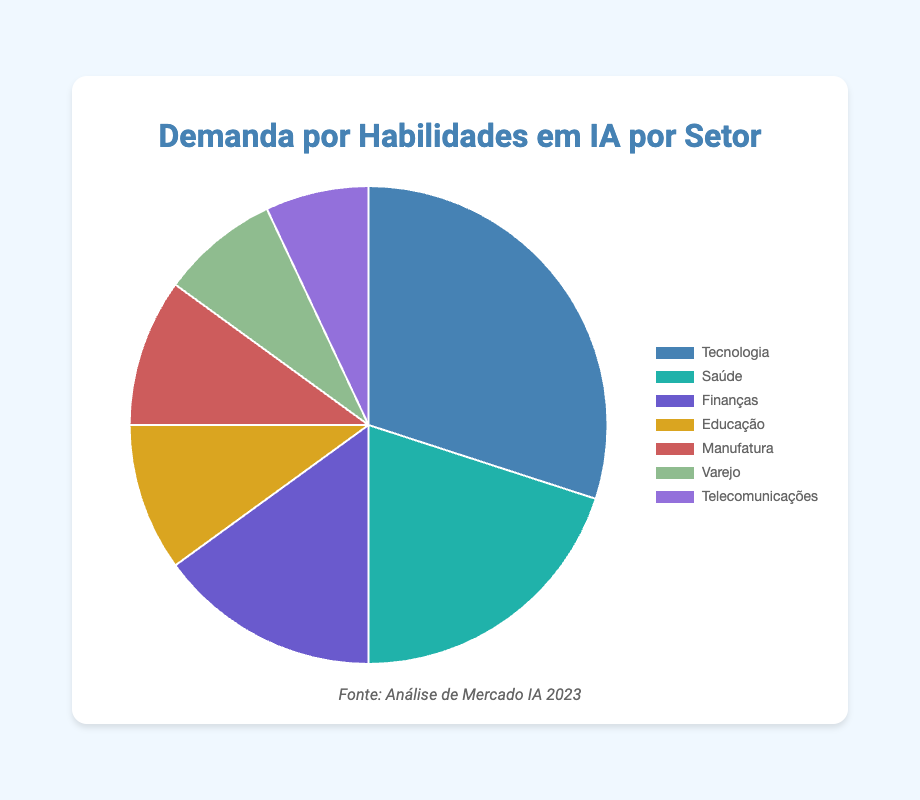Which sector has the highest demand for AI skills? The sector with the highest demand can be identified by the largest segment in the pie chart. The "Technology" sector visually occupies the largest portion with 30%.
Answer: Technology How much higher is the demand for AI skills in healthcare compared to telecommunications? Subtract the demand percentage of the telecommunications sector from the healthcare sector. Healthcare is 20%, and telecommunications is 7%, so 20% - 7% = 13%.
Answer: 13% Which two sectors have an equal demand for AI skills? By observing the sizes and labels of the pie chart segments, both "Education" and "Manufacturing" sectors have a demand of 10%.
Answer: Education and Manufacturing What is the combined demand percentage for AI skills in the finance, retail, and telecommunications sectors? Sum the demand percentages for finance, retail, and telecommunications: 15% (Finance) + 8% (Retail) + 7% (Telecommunications) = 30%.
Answer: 30% How does the demand for AI skills in the education sector compare to the demand in the healthcare sector? Compare the demand percentages for education and healthcare. The education sector has 10%, while the healthcare sector has 20%. Since 20% > 10%, the healthcare sector has a higher demand.
Answer: Healthcare has higher demand Which sector has the smallest demand for AI skills, and what is the percentage? The smallest demand can be identified by the smallest segment of the pie chart. The "Telecommunications" sector represents the smallest portion at 7%.
Answer: Telecommunications (7%) What percentage of the total demand do the technology and healthcare sectors represent? Add the demand percentages for technology and healthcare: 30% (Technology) + 20% (Healthcare) = 50%.
Answer: 50% Is the demand for AI skills in the manufacturing sector greater than that in the retail sector? Compare the demand percentages for manufacturing and retail. The manufacturing sector has 10%, while the retail sector has 8%. Since 10% > 8%, the manufacturing sector has a greater demand.
Answer: Yes What is the average demand percentage across all sectors? Sum all the demand percentages and divide by the number of sectors: (30% + 20% + 15% + 10% + 10% + 8% + 7%) / 7 = 100% / 7 ≈ 14.29%.
Answer: 14.29% 